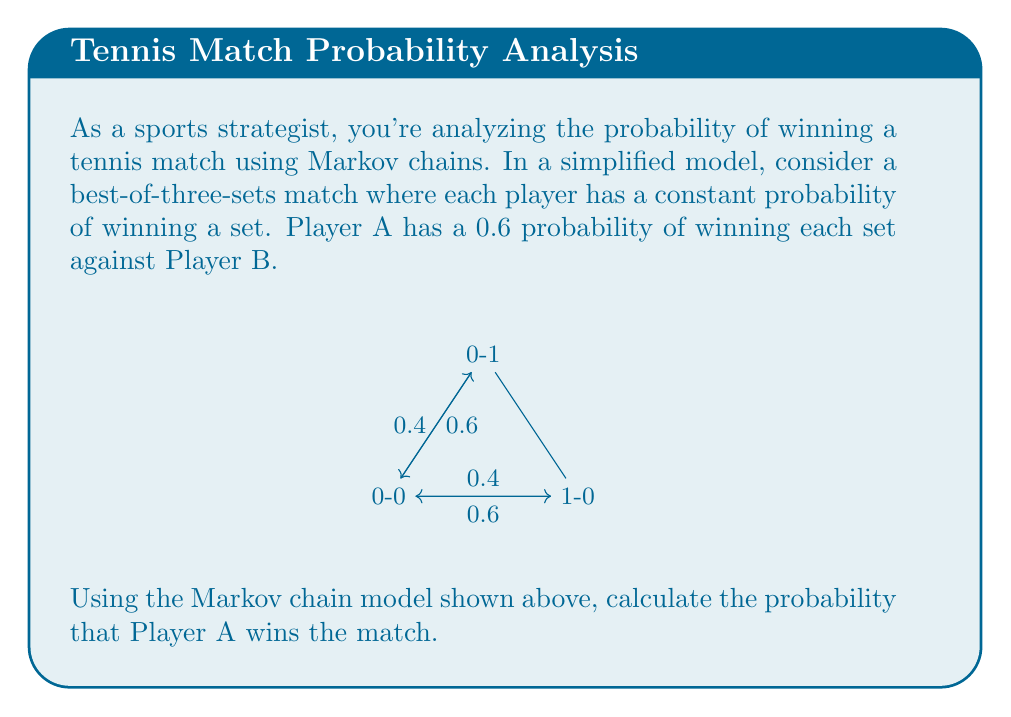Help me with this question. Let's approach this step-by-step using the Markov chain model:

1) First, we need to identify the states and transition probabilities:
   - State 0-0: No player has won a set yet
   - State 1-0: Player A has won one set
   - State 0-1: Player B has won one set
   - Winning states: 2-0 and 2-1 for Player A (not shown in the diagram)

2) The transition probabilities are:
   - P(0-0 to 1-0) = 0.6
   - P(0-0 to 0-1) = 0.4
   - P(1-0 to 2-0) = 0.6
   - P(1-0 to 1-1) = 0.4
   - P(0-1 to 1-1) = 0.6
   - P(0-1 to 0-2) = 0.4

3) Let's define:
   - P(A) = Probability of Player A winning from state 0-0
   - P(B) = Probability of Player A winning from state 1-0
   - P(C) = Probability of Player A winning from state 0-1

4) We can now set up a system of equations:
   P(A) = 0.6P(B) + 0.4P(C)
   P(B) = 0.6 + 0.4P(A)
   P(C) = 0.6P(A)

5) Substituting P(C) into the first equation:
   P(A) = 0.6P(B) + 0.4(0.6P(A))
   P(A) = 0.6P(B) + 0.24P(A)
   0.76P(A) = 0.6P(B)
   P(A) = (5/19)P(B)

6) Substituting this into the second equation:
   P(B) = 0.6 + 0.4((5/19)P(B))
   P(B) = 0.6 + (1/9.5)P(B)
   (8.5/9.5)P(B) = 0.6
   P(B) = 0.6 * (9.5/8.5) = 0.67058...

7) Finally, we can calculate P(A):
   P(A) = (5/19) * 0.67058... = 0.17647...

Therefore, the probability of Player A winning the match is approximately 0.7647 or 76.47%.
Answer: $$0.7647$$ 